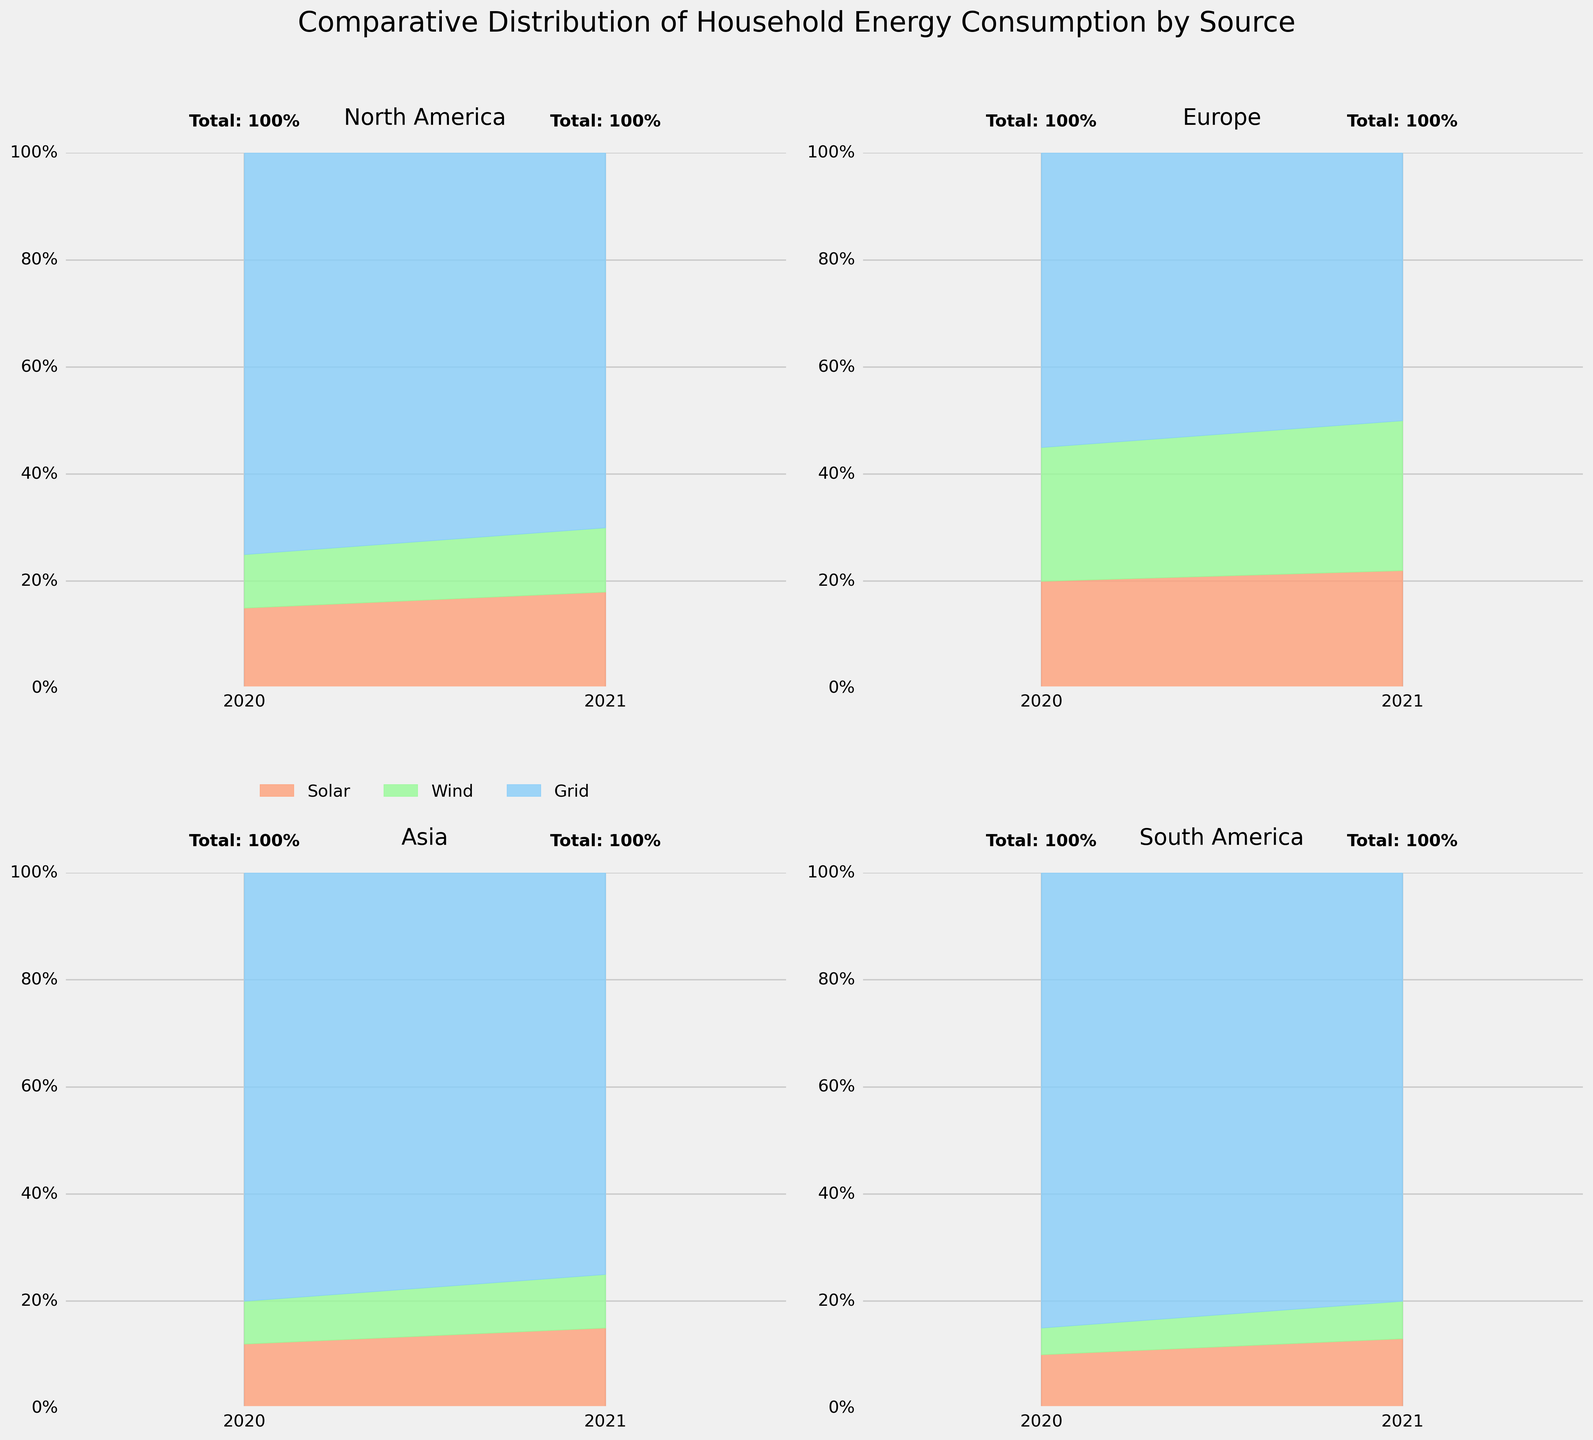How many regions are represented in the figure? The figure shows four subplots, each representing a different region. The regions can be identified by the titles of each subplot.
Answer: Four Which region had the highest percentage of wind energy consumption in 2021? By inspecting the subplot for each region and looking at the wind energy segment for 2021, we see that Europe has the highest wind energy consumption at 28%.
Answer: Europe What is the overall trend for solar energy consumption in North America from 2020 to 2021? By examining the solar energy segment in the North America subplot, we see that solar consumption increased from 15% in 2020 to 18% in 2021.
Answer: Increasing Compare the grid energy consumption in Asia in 2020 and 2021. How much did it decrease? The grid energy consumption in Asia in 2020 was 80% and decreased to 75% in 2021. The difference is 80% - 75% = 5%.
Answer: 5% Which region has the most balanced distribution of energy sources in 2020? By comparing the subplots, we see that Europe has a more balanced distribution among solar (20%), wind (25%), and grid (55%) energy sources in 2020.
Answer: Europe In 2021, which region shows the highest reliance on grid energy? By looking at the grid energy segments in 2021, we see that South America has the highest reliance with 80% grid energy.
Answer: South America What is the combined percentage of solar and wind energy in South America in 2020? In the South America subplot for 2020, solar energy is 10% and wind energy is 5%. Summing these values gives 10% + 5% = 15%.
Answer: 15% Identify the region with the largest increase in wind energy consumption from 2020 to 2021. By examining the wind energy segments in each subplot, we see that Europe increased from 25% in 2020 to 28% in 2021, which is a 3% increase, the largest among the regions.
Answer: Europe What is the combined total percentage for all energy sources in each year for North America? In the North America subplot, we sum the percentages of all energy sources:
2020: 15% (Solar) + 10% (Wind) + 75% (Grid) = 100%
2021: 18% (Solar) + 12% (Wind) + 70% (Grid) = 100%.
Answer: 100% Between 2020 and 2021, did any region see a decrease in solar energy consumption? By looking at the solar energy segments, we see that all regions experienced an increase in solar energy from 2020 to 2021. Therefore, no region saw a decrease.
Answer: No 